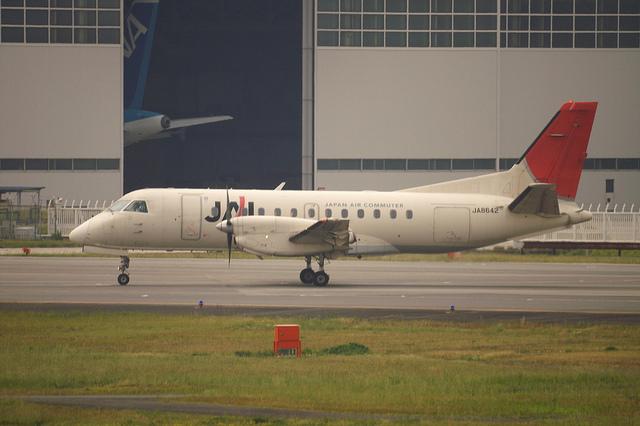Is this an airport?
Short answer required. Yes. How many engines can be seen at this angle?
Write a very short answer. 1. Is there a picture on the tail of the plane?
Give a very brief answer. No. Which plane is smaller?
Quick response, please. Red and white. What direction is the plane going?
Keep it brief. Left. 